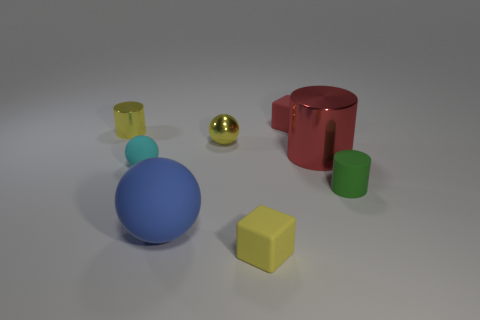There is a ball that is the same color as the tiny metallic cylinder; what material is it?
Your response must be concise. Metal. What number of objects are small green things or small matte cubes in front of the cyan thing?
Ensure brevity in your answer.  2. Are there fewer small metallic objects that are to the right of the large red cylinder than yellow shiny spheres that are in front of the green cylinder?
Provide a succinct answer. No. What number of other things are there of the same material as the small cyan thing
Give a very brief answer. 4. Do the thing that is in front of the big blue rubber thing and the tiny shiny ball have the same color?
Provide a short and direct response. Yes. Are there any tiny objects that are on the right side of the yellow metal thing that is left of the large ball?
Your response must be concise. Yes. There is a small yellow object that is both behind the large red cylinder and on the right side of the small matte ball; what is its material?
Keep it short and to the point. Metal. The large object that is the same material as the red cube is what shape?
Keep it short and to the point. Sphere. Does the yellow thing on the left side of the large blue matte object have the same material as the large cylinder?
Give a very brief answer. Yes. There is a red object that is behind the tiny yellow ball; what is it made of?
Your response must be concise. Rubber. 